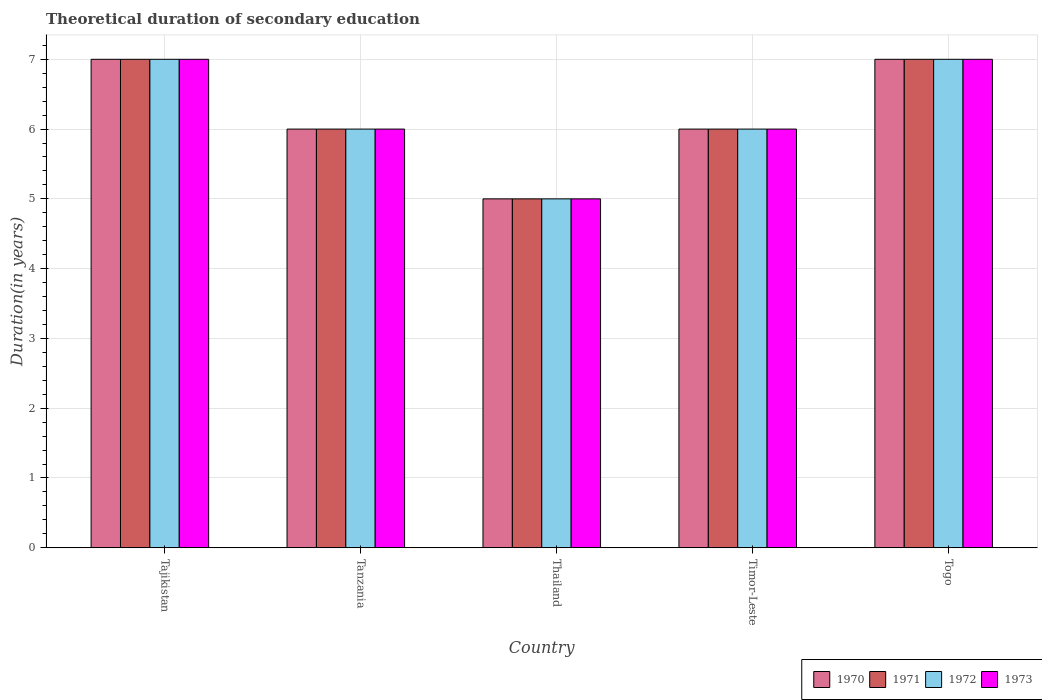How many different coloured bars are there?
Provide a succinct answer. 4. How many groups of bars are there?
Your response must be concise. 5. Are the number of bars per tick equal to the number of legend labels?
Provide a succinct answer. Yes. How many bars are there on the 4th tick from the left?
Provide a short and direct response. 4. What is the label of the 5th group of bars from the left?
Ensure brevity in your answer.  Togo. Across all countries, what is the maximum total theoretical duration of secondary education in 1973?
Make the answer very short. 7. In which country was the total theoretical duration of secondary education in 1973 maximum?
Your answer should be very brief. Tajikistan. In which country was the total theoretical duration of secondary education in 1972 minimum?
Ensure brevity in your answer.  Thailand. What is the difference between the total theoretical duration of secondary education in 1973 in Tanzania and that in Thailand?
Offer a very short reply. 1. What is the average total theoretical duration of secondary education in 1973 per country?
Provide a succinct answer. 6.2. What is the difference between the total theoretical duration of secondary education of/in 1971 and total theoretical duration of secondary education of/in 1972 in Thailand?
Make the answer very short. 0. In how many countries, is the total theoretical duration of secondary education in 1972 greater than 2.6 years?
Offer a very short reply. 5. What is the ratio of the total theoretical duration of secondary education in 1970 in Tanzania to that in Timor-Leste?
Your answer should be compact. 1. Is the total theoretical duration of secondary education in 1970 in Tajikistan less than that in Thailand?
Your response must be concise. No. What is the difference between the highest and the lowest total theoretical duration of secondary education in 1972?
Your answer should be compact. 2. In how many countries, is the total theoretical duration of secondary education in 1972 greater than the average total theoretical duration of secondary education in 1972 taken over all countries?
Ensure brevity in your answer.  2. Is it the case that in every country, the sum of the total theoretical duration of secondary education in 1973 and total theoretical duration of secondary education in 1971 is greater than the sum of total theoretical duration of secondary education in 1972 and total theoretical duration of secondary education in 1970?
Provide a short and direct response. No. What does the 4th bar from the left in Tanzania represents?
Offer a terse response. 1973. How many bars are there?
Your answer should be very brief. 20. How many countries are there in the graph?
Offer a very short reply. 5. What is the difference between two consecutive major ticks on the Y-axis?
Offer a very short reply. 1. Does the graph contain any zero values?
Your answer should be very brief. No. Where does the legend appear in the graph?
Your answer should be compact. Bottom right. How are the legend labels stacked?
Your answer should be compact. Horizontal. What is the title of the graph?
Offer a very short reply. Theoretical duration of secondary education. Does "1996" appear as one of the legend labels in the graph?
Keep it short and to the point. No. What is the label or title of the Y-axis?
Provide a succinct answer. Duration(in years). What is the Duration(in years) of 1973 in Tajikistan?
Offer a terse response. 7. What is the Duration(in years) in 1972 in Tanzania?
Your answer should be very brief. 6. What is the Duration(in years) of 1973 in Thailand?
Keep it short and to the point. 5. What is the Duration(in years) in 1971 in Timor-Leste?
Provide a succinct answer. 6. What is the Duration(in years) in 1972 in Togo?
Ensure brevity in your answer.  7. Across all countries, what is the maximum Duration(in years) of 1970?
Your answer should be compact. 7. Across all countries, what is the maximum Duration(in years) in 1972?
Provide a succinct answer. 7. Across all countries, what is the maximum Duration(in years) in 1973?
Offer a terse response. 7. Across all countries, what is the minimum Duration(in years) in 1970?
Your answer should be very brief. 5. Across all countries, what is the minimum Duration(in years) of 1972?
Offer a very short reply. 5. What is the difference between the Duration(in years) in 1971 in Tajikistan and that in Tanzania?
Provide a short and direct response. 1. What is the difference between the Duration(in years) in 1972 in Tajikistan and that in Tanzania?
Give a very brief answer. 1. What is the difference between the Duration(in years) of 1970 in Tajikistan and that in Timor-Leste?
Offer a very short reply. 1. What is the difference between the Duration(in years) in 1972 in Tajikistan and that in Timor-Leste?
Your response must be concise. 1. What is the difference between the Duration(in years) of 1973 in Tajikistan and that in Timor-Leste?
Keep it short and to the point. 1. What is the difference between the Duration(in years) of 1971 in Tajikistan and that in Togo?
Ensure brevity in your answer.  0. What is the difference between the Duration(in years) of 1972 in Tajikistan and that in Togo?
Your response must be concise. 0. What is the difference between the Duration(in years) of 1973 in Tanzania and that in Thailand?
Ensure brevity in your answer.  1. What is the difference between the Duration(in years) of 1973 in Tanzania and that in Timor-Leste?
Offer a terse response. 0. What is the difference between the Duration(in years) of 1971 in Tanzania and that in Togo?
Offer a very short reply. -1. What is the difference between the Duration(in years) in 1972 in Tanzania and that in Togo?
Your answer should be compact. -1. What is the difference between the Duration(in years) in 1973 in Tanzania and that in Togo?
Your answer should be very brief. -1. What is the difference between the Duration(in years) in 1970 in Thailand and that in Timor-Leste?
Provide a short and direct response. -1. What is the difference between the Duration(in years) of 1971 in Thailand and that in Timor-Leste?
Ensure brevity in your answer.  -1. What is the difference between the Duration(in years) in 1973 in Thailand and that in Timor-Leste?
Make the answer very short. -1. What is the difference between the Duration(in years) in 1970 in Thailand and that in Togo?
Give a very brief answer. -2. What is the difference between the Duration(in years) of 1972 in Thailand and that in Togo?
Offer a terse response. -2. What is the difference between the Duration(in years) in 1970 in Timor-Leste and that in Togo?
Make the answer very short. -1. What is the difference between the Duration(in years) in 1971 in Timor-Leste and that in Togo?
Keep it short and to the point. -1. What is the difference between the Duration(in years) of 1972 in Timor-Leste and that in Togo?
Give a very brief answer. -1. What is the difference between the Duration(in years) of 1973 in Timor-Leste and that in Togo?
Ensure brevity in your answer.  -1. What is the difference between the Duration(in years) of 1970 in Tajikistan and the Duration(in years) of 1971 in Tanzania?
Keep it short and to the point. 1. What is the difference between the Duration(in years) of 1970 in Tajikistan and the Duration(in years) of 1973 in Tanzania?
Provide a succinct answer. 1. What is the difference between the Duration(in years) in 1971 in Tajikistan and the Duration(in years) in 1973 in Tanzania?
Provide a succinct answer. 1. What is the difference between the Duration(in years) in 1972 in Tajikistan and the Duration(in years) in 1973 in Tanzania?
Make the answer very short. 1. What is the difference between the Duration(in years) of 1970 in Tajikistan and the Duration(in years) of 1971 in Thailand?
Make the answer very short. 2. What is the difference between the Duration(in years) in 1970 in Tajikistan and the Duration(in years) in 1972 in Thailand?
Your answer should be very brief. 2. What is the difference between the Duration(in years) in 1971 in Tajikistan and the Duration(in years) in 1972 in Thailand?
Provide a succinct answer. 2. What is the difference between the Duration(in years) of 1972 in Tajikistan and the Duration(in years) of 1973 in Thailand?
Make the answer very short. 2. What is the difference between the Duration(in years) of 1970 in Tajikistan and the Duration(in years) of 1971 in Timor-Leste?
Offer a terse response. 1. What is the difference between the Duration(in years) of 1971 in Tajikistan and the Duration(in years) of 1972 in Timor-Leste?
Provide a succinct answer. 1. What is the difference between the Duration(in years) in 1971 in Tajikistan and the Duration(in years) in 1973 in Timor-Leste?
Your response must be concise. 1. What is the difference between the Duration(in years) of 1970 in Tajikistan and the Duration(in years) of 1971 in Togo?
Offer a very short reply. 0. What is the difference between the Duration(in years) in 1970 in Tanzania and the Duration(in years) in 1971 in Thailand?
Offer a terse response. 1. What is the difference between the Duration(in years) in 1970 in Tanzania and the Duration(in years) in 1972 in Thailand?
Offer a terse response. 1. What is the difference between the Duration(in years) in 1970 in Tanzania and the Duration(in years) in 1973 in Thailand?
Keep it short and to the point. 1. What is the difference between the Duration(in years) of 1971 in Tanzania and the Duration(in years) of 1972 in Thailand?
Your response must be concise. 1. What is the difference between the Duration(in years) in 1971 in Tanzania and the Duration(in years) in 1973 in Thailand?
Give a very brief answer. 1. What is the difference between the Duration(in years) in 1972 in Tanzania and the Duration(in years) in 1973 in Thailand?
Offer a very short reply. 1. What is the difference between the Duration(in years) in 1970 in Tanzania and the Duration(in years) in 1971 in Timor-Leste?
Provide a short and direct response. 0. What is the difference between the Duration(in years) in 1971 in Tanzania and the Duration(in years) in 1972 in Timor-Leste?
Ensure brevity in your answer.  0. What is the difference between the Duration(in years) in 1972 in Tanzania and the Duration(in years) in 1973 in Timor-Leste?
Your answer should be very brief. 0. What is the difference between the Duration(in years) of 1970 in Tanzania and the Duration(in years) of 1973 in Togo?
Make the answer very short. -1. What is the difference between the Duration(in years) of 1971 in Tanzania and the Duration(in years) of 1972 in Togo?
Provide a short and direct response. -1. What is the difference between the Duration(in years) in 1972 in Tanzania and the Duration(in years) in 1973 in Togo?
Ensure brevity in your answer.  -1. What is the difference between the Duration(in years) of 1970 in Thailand and the Duration(in years) of 1971 in Timor-Leste?
Offer a terse response. -1. What is the difference between the Duration(in years) in 1970 in Thailand and the Duration(in years) in 1972 in Timor-Leste?
Give a very brief answer. -1. What is the difference between the Duration(in years) in 1971 in Thailand and the Duration(in years) in 1972 in Timor-Leste?
Your answer should be very brief. -1. What is the difference between the Duration(in years) of 1971 in Thailand and the Duration(in years) of 1973 in Timor-Leste?
Provide a short and direct response. -1. What is the difference between the Duration(in years) of 1972 in Thailand and the Duration(in years) of 1973 in Timor-Leste?
Your answer should be very brief. -1. What is the difference between the Duration(in years) of 1970 in Thailand and the Duration(in years) of 1972 in Togo?
Provide a short and direct response. -2. What is the difference between the Duration(in years) of 1970 in Thailand and the Duration(in years) of 1973 in Togo?
Your answer should be compact. -2. What is the difference between the Duration(in years) of 1971 in Thailand and the Duration(in years) of 1972 in Togo?
Your response must be concise. -2. What is the difference between the Duration(in years) of 1970 in Timor-Leste and the Duration(in years) of 1972 in Togo?
Your answer should be very brief. -1. What is the difference between the Duration(in years) of 1970 in Timor-Leste and the Duration(in years) of 1973 in Togo?
Provide a succinct answer. -1. What is the difference between the Duration(in years) in 1971 in Timor-Leste and the Duration(in years) in 1972 in Togo?
Give a very brief answer. -1. What is the difference between the Duration(in years) of 1971 in Timor-Leste and the Duration(in years) of 1973 in Togo?
Make the answer very short. -1. What is the average Duration(in years) in 1972 per country?
Keep it short and to the point. 6.2. What is the difference between the Duration(in years) in 1970 and Duration(in years) in 1972 in Tajikistan?
Your answer should be compact. 0. What is the difference between the Duration(in years) in 1971 and Duration(in years) in 1972 in Tajikistan?
Your response must be concise. 0. What is the difference between the Duration(in years) in 1971 and Duration(in years) in 1973 in Tajikistan?
Provide a short and direct response. 0. What is the difference between the Duration(in years) in 1972 and Duration(in years) in 1973 in Tajikistan?
Offer a very short reply. 0. What is the difference between the Duration(in years) in 1970 and Duration(in years) in 1971 in Tanzania?
Provide a succinct answer. 0. What is the difference between the Duration(in years) of 1970 and Duration(in years) of 1972 in Tanzania?
Make the answer very short. 0. What is the difference between the Duration(in years) in 1972 and Duration(in years) in 1973 in Tanzania?
Provide a succinct answer. 0. What is the difference between the Duration(in years) of 1970 and Duration(in years) of 1971 in Thailand?
Your response must be concise. 0. What is the difference between the Duration(in years) in 1970 and Duration(in years) in 1973 in Thailand?
Make the answer very short. 0. What is the difference between the Duration(in years) of 1971 and Duration(in years) of 1972 in Thailand?
Provide a succinct answer. 0. What is the difference between the Duration(in years) in 1970 and Duration(in years) in 1973 in Timor-Leste?
Keep it short and to the point. 0. What is the difference between the Duration(in years) in 1971 and Duration(in years) in 1972 in Timor-Leste?
Offer a terse response. 0. What is the difference between the Duration(in years) in 1971 and Duration(in years) in 1973 in Timor-Leste?
Provide a succinct answer. 0. What is the difference between the Duration(in years) in 1972 and Duration(in years) in 1973 in Timor-Leste?
Ensure brevity in your answer.  0. What is the difference between the Duration(in years) in 1970 and Duration(in years) in 1971 in Togo?
Keep it short and to the point. 0. What is the difference between the Duration(in years) of 1970 and Duration(in years) of 1973 in Togo?
Offer a very short reply. 0. What is the difference between the Duration(in years) of 1971 and Duration(in years) of 1972 in Togo?
Your answer should be compact. 0. What is the ratio of the Duration(in years) of 1970 in Tajikistan to that in Tanzania?
Offer a terse response. 1.17. What is the ratio of the Duration(in years) in 1971 in Tajikistan to that in Tanzania?
Offer a very short reply. 1.17. What is the ratio of the Duration(in years) of 1970 in Tajikistan to that in Thailand?
Offer a very short reply. 1.4. What is the ratio of the Duration(in years) in 1973 in Tajikistan to that in Thailand?
Keep it short and to the point. 1.4. What is the ratio of the Duration(in years) in 1972 in Tajikistan to that in Timor-Leste?
Provide a succinct answer. 1.17. What is the ratio of the Duration(in years) in 1970 in Tajikistan to that in Togo?
Your answer should be very brief. 1. What is the ratio of the Duration(in years) of 1972 in Tanzania to that in Timor-Leste?
Provide a short and direct response. 1. What is the ratio of the Duration(in years) of 1973 in Tanzania to that in Timor-Leste?
Provide a short and direct response. 1. What is the ratio of the Duration(in years) in 1971 in Tanzania to that in Togo?
Keep it short and to the point. 0.86. What is the ratio of the Duration(in years) in 1972 in Tanzania to that in Togo?
Provide a short and direct response. 0.86. What is the ratio of the Duration(in years) of 1970 in Thailand to that in Timor-Leste?
Provide a short and direct response. 0.83. What is the ratio of the Duration(in years) of 1972 in Thailand to that in Togo?
Your response must be concise. 0.71. What is the ratio of the Duration(in years) in 1973 in Thailand to that in Togo?
Ensure brevity in your answer.  0.71. What is the ratio of the Duration(in years) in 1971 in Timor-Leste to that in Togo?
Give a very brief answer. 0.86. What is the ratio of the Duration(in years) of 1972 in Timor-Leste to that in Togo?
Offer a very short reply. 0.86. What is the ratio of the Duration(in years) of 1973 in Timor-Leste to that in Togo?
Ensure brevity in your answer.  0.86. What is the difference between the highest and the second highest Duration(in years) in 1970?
Provide a succinct answer. 0. What is the difference between the highest and the lowest Duration(in years) in 1971?
Ensure brevity in your answer.  2. 